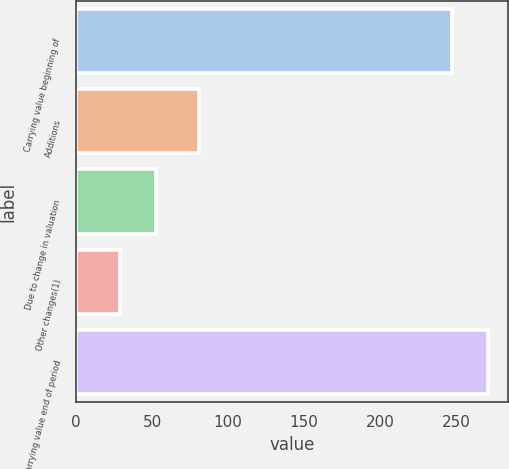Convert chart. <chart><loc_0><loc_0><loc_500><loc_500><bar_chart><fcel>Carrying value beginning of<fcel>Additions<fcel>Due to change in valuation<fcel>Other changes(1)<fcel>Carrying value end of period<nl><fcel>247<fcel>81<fcel>52.8<fcel>29<fcel>270.8<nl></chart> 